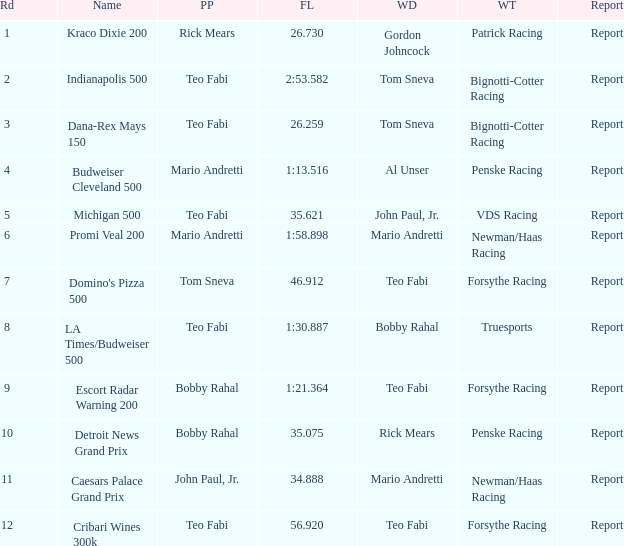What was the fastest lap time in the Escort Radar Warning 200? 1:21.364. Would you mind parsing the complete table? {'header': ['Rd', 'Name', 'PP', 'FL', 'WD', 'WT', 'Report'], 'rows': [['1', 'Kraco Dixie 200', 'Rick Mears', '26.730', 'Gordon Johncock', 'Patrick Racing', 'Report'], ['2', 'Indianapolis 500', 'Teo Fabi', '2:53.582', 'Tom Sneva', 'Bignotti-Cotter Racing', 'Report'], ['3', 'Dana-Rex Mays 150', 'Teo Fabi', '26.259', 'Tom Sneva', 'Bignotti-Cotter Racing', 'Report'], ['4', 'Budweiser Cleveland 500', 'Mario Andretti', '1:13.516', 'Al Unser', 'Penske Racing', 'Report'], ['5', 'Michigan 500', 'Teo Fabi', '35.621', 'John Paul, Jr.', 'VDS Racing', 'Report'], ['6', 'Promi Veal 200', 'Mario Andretti', '1:58.898', 'Mario Andretti', 'Newman/Haas Racing', 'Report'], ['7', "Domino's Pizza 500", 'Tom Sneva', '46.912', 'Teo Fabi', 'Forsythe Racing', 'Report'], ['8', 'LA Times/Budweiser 500', 'Teo Fabi', '1:30.887', 'Bobby Rahal', 'Truesports', 'Report'], ['9', 'Escort Radar Warning 200', 'Bobby Rahal', '1:21.364', 'Teo Fabi', 'Forsythe Racing', 'Report'], ['10', 'Detroit News Grand Prix', 'Bobby Rahal', '35.075', 'Rick Mears', 'Penske Racing', 'Report'], ['11', 'Caesars Palace Grand Prix', 'John Paul, Jr.', '34.888', 'Mario Andretti', 'Newman/Haas Racing', 'Report'], ['12', 'Cribari Wines 300k', 'Teo Fabi', '56.920', 'Teo Fabi', 'Forsythe Racing', 'Report']]} 